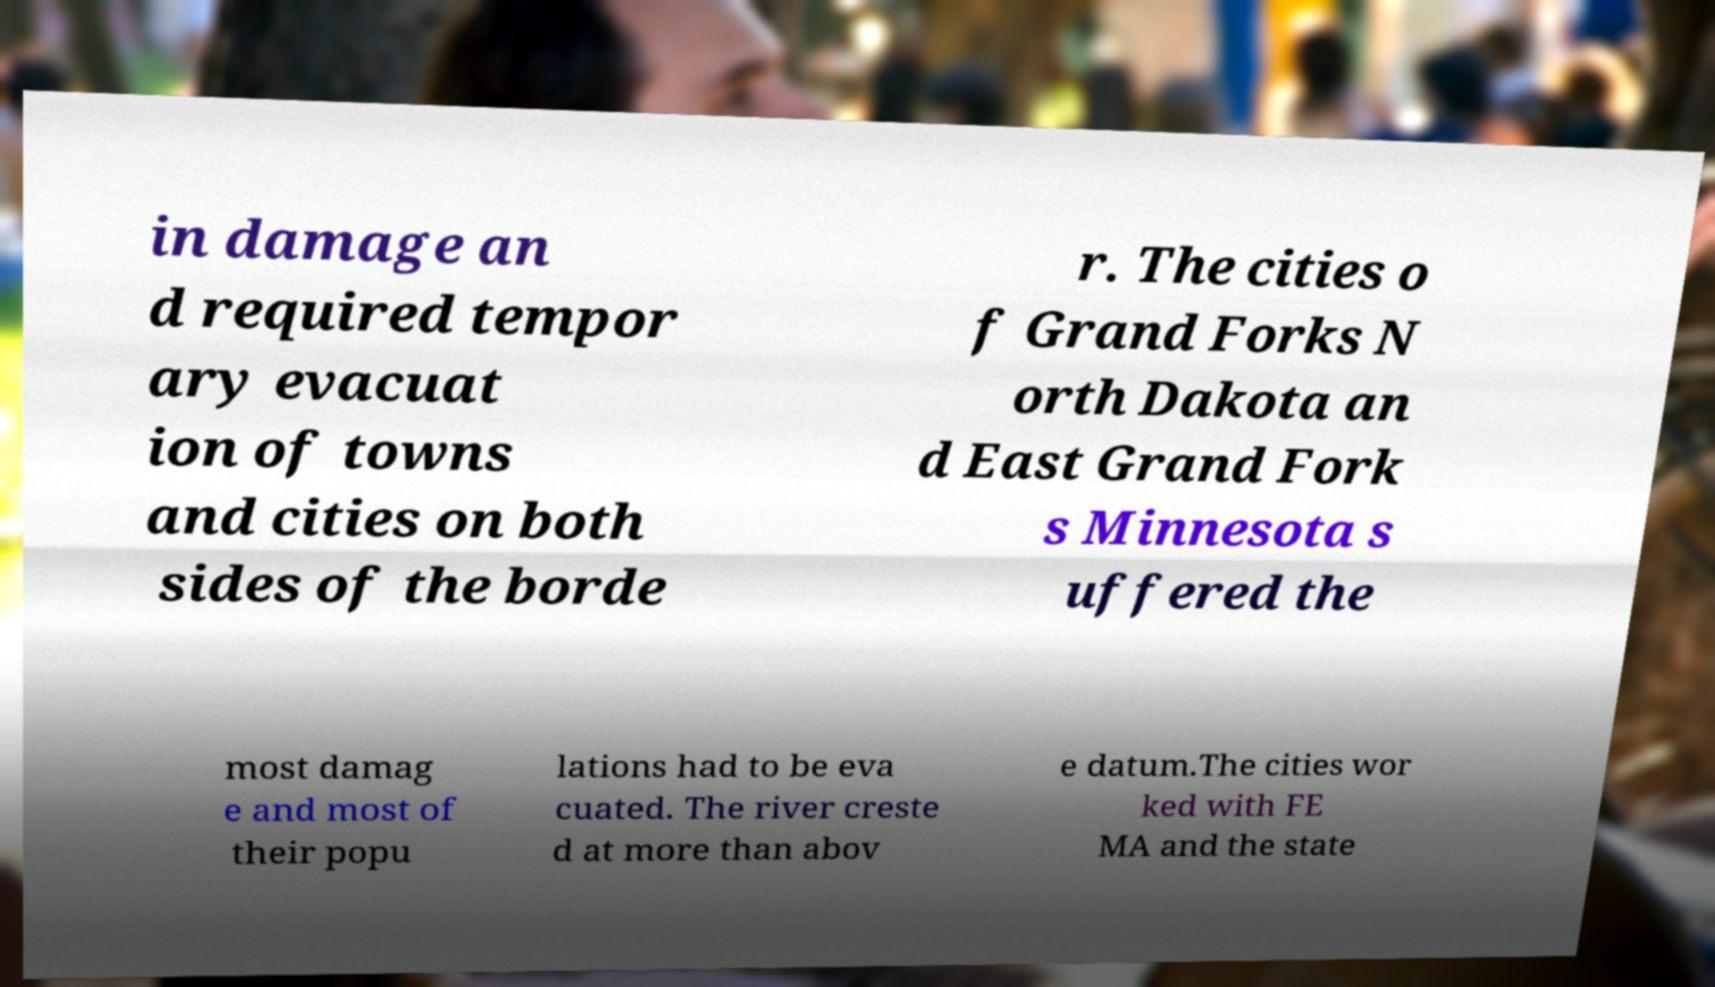There's text embedded in this image that I need extracted. Can you transcribe it verbatim? in damage an d required tempor ary evacuat ion of towns and cities on both sides of the borde r. The cities o f Grand Forks N orth Dakota an d East Grand Fork s Minnesota s uffered the most damag e and most of their popu lations had to be eva cuated. The river creste d at more than abov e datum.The cities wor ked with FE MA and the state 